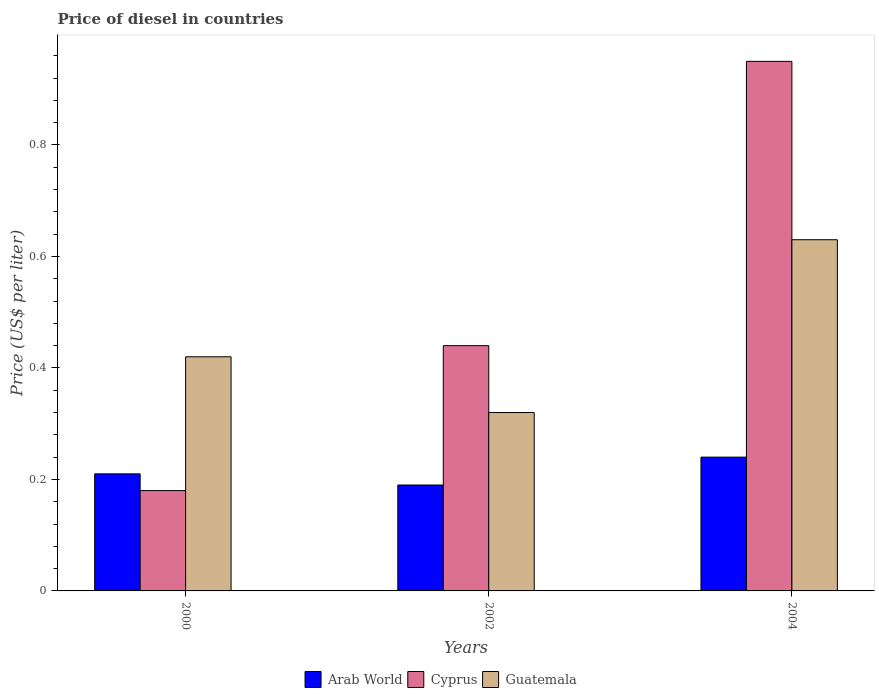How many groups of bars are there?
Provide a succinct answer. 3. Are the number of bars per tick equal to the number of legend labels?
Keep it short and to the point. Yes. Are the number of bars on each tick of the X-axis equal?
Offer a very short reply. Yes. How many bars are there on the 2nd tick from the left?
Your answer should be very brief. 3. What is the label of the 1st group of bars from the left?
Provide a short and direct response. 2000. What is the price of diesel in Arab World in 2004?
Keep it short and to the point. 0.24. Across all years, what is the maximum price of diesel in Guatemala?
Make the answer very short. 0.63. Across all years, what is the minimum price of diesel in Guatemala?
Your answer should be compact. 0.32. What is the total price of diesel in Guatemala in the graph?
Make the answer very short. 1.37. What is the difference between the price of diesel in Cyprus in 2000 and that in 2002?
Your response must be concise. -0.26. What is the difference between the price of diesel in Guatemala in 2002 and the price of diesel in Cyprus in 2004?
Provide a short and direct response. -0.63. What is the average price of diesel in Arab World per year?
Keep it short and to the point. 0.21. In the year 2004, what is the difference between the price of diesel in Guatemala and price of diesel in Arab World?
Your answer should be very brief. 0.39. In how many years, is the price of diesel in Arab World greater than 0.4 US$?
Offer a terse response. 0. What is the ratio of the price of diesel in Arab World in 2002 to that in 2004?
Ensure brevity in your answer.  0.79. Is the price of diesel in Cyprus in 2000 less than that in 2004?
Ensure brevity in your answer.  Yes. Is the difference between the price of diesel in Guatemala in 2000 and 2002 greater than the difference between the price of diesel in Arab World in 2000 and 2002?
Your answer should be compact. Yes. What is the difference between the highest and the second highest price of diesel in Guatemala?
Provide a short and direct response. 0.21. What is the difference between the highest and the lowest price of diesel in Arab World?
Provide a succinct answer. 0.05. In how many years, is the price of diesel in Guatemala greater than the average price of diesel in Guatemala taken over all years?
Make the answer very short. 1. What does the 1st bar from the left in 2002 represents?
Your response must be concise. Arab World. What does the 2nd bar from the right in 2004 represents?
Provide a short and direct response. Cyprus. Is it the case that in every year, the sum of the price of diesel in Arab World and price of diesel in Cyprus is greater than the price of diesel in Guatemala?
Your answer should be compact. No. How many bars are there?
Offer a terse response. 9. How many years are there in the graph?
Ensure brevity in your answer.  3. Are the values on the major ticks of Y-axis written in scientific E-notation?
Your answer should be compact. No. Where does the legend appear in the graph?
Offer a terse response. Bottom center. How many legend labels are there?
Provide a succinct answer. 3. How are the legend labels stacked?
Provide a short and direct response. Horizontal. What is the title of the graph?
Your answer should be very brief. Price of diesel in countries. Does "Cameroon" appear as one of the legend labels in the graph?
Provide a short and direct response. No. What is the label or title of the Y-axis?
Give a very brief answer. Price (US$ per liter). What is the Price (US$ per liter) of Arab World in 2000?
Ensure brevity in your answer.  0.21. What is the Price (US$ per liter) of Cyprus in 2000?
Offer a terse response. 0.18. What is the Price (US$ per liter) in Guatemala in 2000?
Provide a succinct answer. 0.42. What is the Price (US$ per liter) of Arab World in 2002?
Ensure brevity in your answer.  0.19. What is the Price (US$ per liter) of Cyprus in 2002?
Make the answer very short. 0.44. What is the Price (US$ per liter) in Guatemala in 2002?
Provide a short and direct response. 0.32. What is the Price (US$ per liter) of Arab World in 2004?
Your response must be concise. 0.24. What is the Price (US$ per liter) of Guatemala in 2004?
Your response must be concise. 0.63. Across all years, what is the maximum Price (US$ per liter) of Arab World?
Offer a terse response. 0.24. Across all years, what is the maximum Price (US$ per liter) in Cyprus?
Provide a succinct answer. 0.95. Across all years, what is the maximum Price (US$ per liter) of Guatemala?
Offer a very short reply. 0.63. Across all years, what is the minimum Price (US$ per liter) in Arab World?
Offer a very short reply. 0.19. Across all years, what is the minimum Price (US$ per liter) of Cyprus?
Give a very brief answer. 0.18. Across all years, what is the minimum Price (US$ per liter) in Guatemala?
Provide a succinct answer. 0.32. What is the total Price (US$ per liter) in Arab World in the graph?
Keep it short and to the point. 0.64. What is the total Price (US$ per liter) in Cyprus in the graph?
Your response must be concise. 1.57. What is the total Price (US$ per liter) in Guatemala in the graph?
Keep it short and to the point. 1.37. What is the difference between the Price (US$ per liter) of Arab World in 2000 and that in 2002?
Provide a succinct answer. 0.02. What is the difference between the Price (US$ per liter) of Cyprus in 2000 and that in 2002?
Give a very brief answer. -0.26. What is the difference between the Price (US$ per liter) in Arab World in 2000 and that in 2004?
Ensure brevity in your answer.  -0.03. What is the difference between the Price (US$ per liter) in Cyprus in 2000 and that in 2004?
Offer a terse response. -0.77. What is the difference between the Price (US$ per liter) in Guatemala in 2000 and that in 2004?
Your answer should be compact. -0.21. What is the difference between the Price (US$ per liter) in Cyprus in 2002 and that in 2004?
Make the answer very short. -0.51. What is the difference between the Price (US$ per liter) in Guatemala in 2002 and that in 2004?
Offer a very short reply. -0.31. What is the difference between the Price (US$ per liter) in Arab World in 2000 and the Price (US$ per liter) in Cyprus in 2002?
Your answer should be compact. -0.23. What is the difference between the Price (US$ per liter) of Arab World in 2000 and the Price (US$ per liter) of Guatemala in 2002?
Provide a succinct answer. -0.11. What is the difference between the Price (US$ per liter) of Cyprus in 2000 and the Price (US$ per liter) of Guatemala in 2002?
Keep it short and to the point. -0.14. What is the difference between the Price (US$ per liter) of Arab World in 2000 and the Price (US$ per liter) of Cyprus in 2004?
Your response must be concise. -0.74. What is the difference between the Price (US$ per liter) of Arab World in 2000 and the Price (US$ per liter) of Guatemala in 2004?
Make the answer very short. -0.42. What is the difference between the Price (US$ per liter) in Cyprus in 2000 and the Price (US$ per liter) in Guatemala in 2004?
Provide a succinct answer. -0.45. What is the difference between the Price (US$ per liter) in Arab World in 2002 and the Price (US$ per liter) in Cyprus in 2004?
Your answer should be compact. -0.76. What is the difference between the Price (US$ per liter) of Arab World in 2002 and the Price (US$ per liter) of Guatemala in 2004?
Your response must be concise. -0.44. What is the difference between the Price (US$ per liter) of Cyprus in 2002 and the Price (US$ per liter) of Guatemala in 2004?
Give a very brief answer. -0.19. What is the average Price (US$ per liter) of Arab World per year?
Your response must be concise. 0.21. What is the average Price (US$ per liter) in Cyprus per year?
Give a very brief answer. 0.52. What is the average Price (US$ per liter) of Guatemala per year?
Give a very brief answer. 0.46. In the year 2000, what is the difference between the Price (US$ per liter) in Arab World and Price (US$ per liter) in Guatemala?
Offer a very short reply. -0.21. In the year 2000, what is the difference between the Price (US$ per liter) in Cyprus and Price (US$ per liter) in Guatemala?
Offer a terse response. -0.24. In the year 2002, what is the difference between the Price (US$ per liter) of Arab World and Price (US$ per liter) of Cyprus?
Make the answer very short. -0.25. In the year 2002, what is the difference between the Price (US$ per liter) in Arab World and Price (US$ per liter) in Guatemala?
Your answer should be very brief. -0.13. In the year 2002, what is the difference between the Price (US$ per liter) of Cyprus and Price (US$ per liter) of Guatemala?
Offer a very short reply. 0.12. In the year 2004, what is the difference between the Price (US$ per liter) of Arab World and Price (US$ per liter) of Cyprus?
Keep it short and to the point. -0.71. In the year 2004, what is the difference between the Price (US$ per liter) of Arab World and Price (US$ per liter) of Guatemala?
Ensure brevity in your answer.  -0.39. In the year 2004, what is the difference between the Price (US$ per liter) of Cyprus and Price (US$ per liter) of Guatemala?
Give a very brief answer. 0.32. What is the ratio of the Price (US$ per liter) in Arab World in 2000 to that in 2002?
Offer a very short reply. 1.11. What is the ratio of the Price (US$ per liter) of Cyprus in 2000 to that in 2002?
Your response must be concise. 0.41. What is the ratio of the Price (US$ per liter) in Guatemala in 2000 to that in 2002?
Give a very brief answer. 1.31. What is the ratio of the Price (US$ per liter) of Arab World in 2000 to that in 2004?
Ensure brevity in your answer.  0.88. What is the ratio of the Price (US$ per liter) of Cyprus in 2000 to that in 2004?
Make the answer very short. 0.19. What is the ratio of the Price (US$ per liter) in Arab World in 2002 to that in 2004?
Provide a succinct answer. 0.79. What is the ratio of the Price (US$ per liter) in Cyprus in 2002 to that in 2004?
Your answer should be compact. 0.46. What is the ratio of the Price (US$ per liter) of Guatemala in 2002 to that in 2004?
Ensure brevity in your answer.  0.51. What is the difference between the highest and the second highest Price (US$ per liter) of Arab World?
Keep it short and to the point. 0.03. What is the difference between the highest and the second highest Price (US$ per liter) in Cyprus?
Offer a terse response. 0.51. What is the difference between the highest and the second highest Price (US$ per liter) of Guatemala?
Keep it short and to the point. 0.21. What is the difference between the highest and the lowest Price (US$ per liter) of Arab World?
Make the answer very short. 0.05. What is the difference between the highest and the lowest Price (US$ per liter) in Cyprus?
Offer a very short reply. 0.77. What is the difference between the highest and the lowest Price (US$ per liter) of Guatemala?
Ensure brevity in your answer.  0.31. 